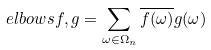Convert formula to latex. <formula><loc_0><loc_0><loc_500><loc_500>\ e l b o w s { f , g } = \sum _ { \omega \in \Omega _ { n } } \overline { f ( \omega ) } g ( \omega )</formula> 